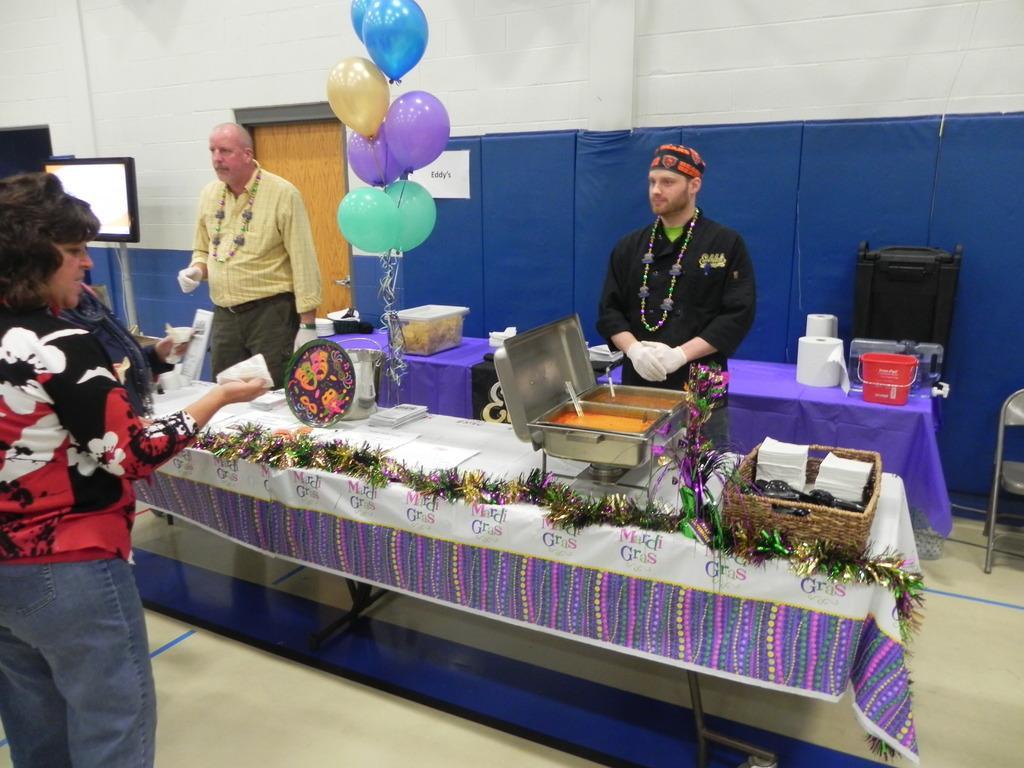Could you give a brief overview of what you see in this image? This image is taken indoors. At the bottom of the image there is a floor. In the background there is a wall with a door. In the middle of the image there are two tables with tablecloths and many things on them and two men are standing on the floor. There are a few balloons. On the right side of the image there is an empty chair. On the left side of the image a woman is standing on the floor and there is a monitor. 